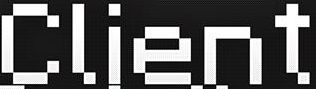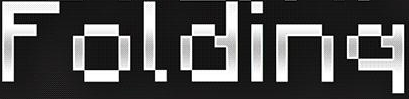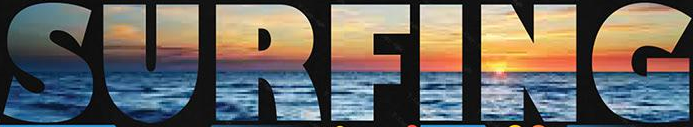What text appears in these images from left to right, separated by a semicolon? Client; Folding; SURFING 